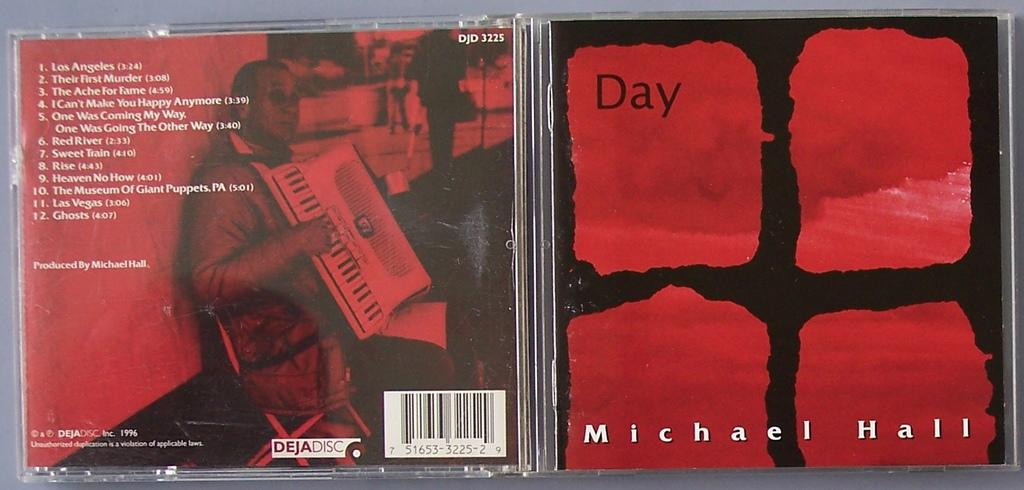<image>
Relay a brief, clear account of the picture shown. The front and back cover of the album Day by Michael Hall. 